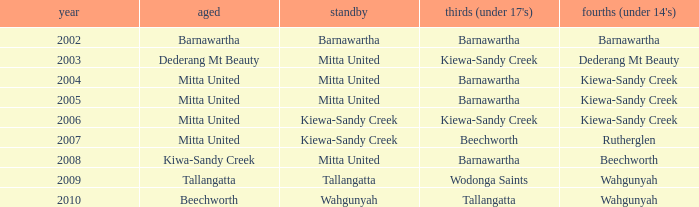Help me parse the entirety of this table. {'header': ['year', 'aged', 'standby', "thirds (under 17's)", "fourths (under 14's)"], 'rows': [['2002', 'Barnawartha', 'Barnawartha', 'Barnawartha', 'Barnawartha'], ['2003', 'Dederang Mt Beauty', 'Mitta United', 'Kiewa-Sandy Creek', 'Dederang Mt Beauty'], ['2004', 'Mitta United', 'Mitta United', 'Barnawartha', 'Kiewa-Sandy Creek'], ['2005', 'Mitta United', 'Mitta United', 'Barnawartha', 'Kiewa-Sandy Creek'], ['2006', 'Mitta United', 'Kiewa-Sandy Creek', 'Kiewa-Sandy Creek', 'Kiewa-Sandy Creek'], ['2007', 'Mitta United', 'Kiewa-Sandy Creek', 'Beechworth', 'Rutherglen'], ['2008', 'Kiwa-Sandy Creek', 'Mitta United', 'Barnawartha', 'Beechworth'], ['2009', 'Tallangatta', 'Tallangatta', 'Wodonga Saints', 'Wahgunyah'], ['2010', 'Beechworth', 'Wahgunyah', 'Tallangatta', 'Wahgunyah']]} Which seniors have a year after 2005, a Reserve of kiewa-sandy creek, and Fourths (Under 14's) of kiewa-sandy creek? Mitta United. 